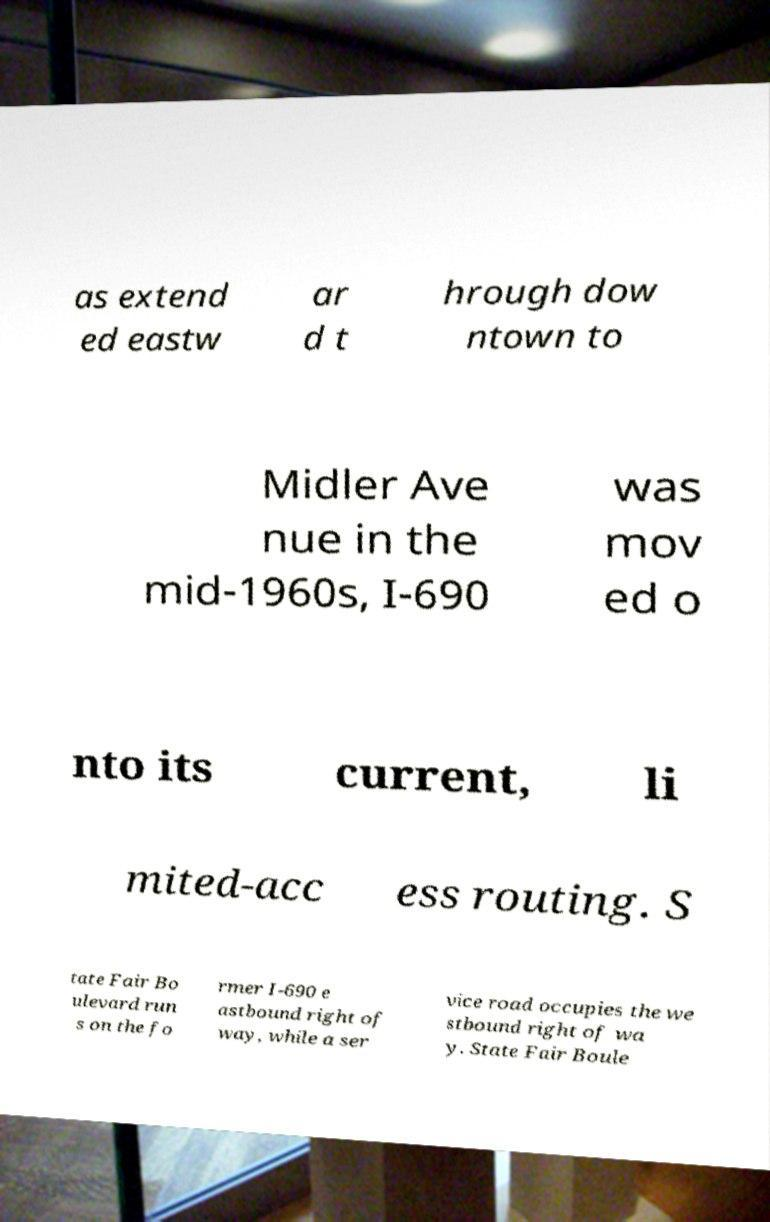Can you accurately transcribe the text from the provided image for me? as extend ed eastw ar d t hrough dow ntown to Midler Ave nue in the mid-1960s, I-690 was mov ed o nto its current, li mited-acc ess routing. S tate Fair Bo ulevard run s on the fo rmer I-690 e astbound right of way, while a ser vice road occupies the we stbound right of wa y. State Fair Boule 